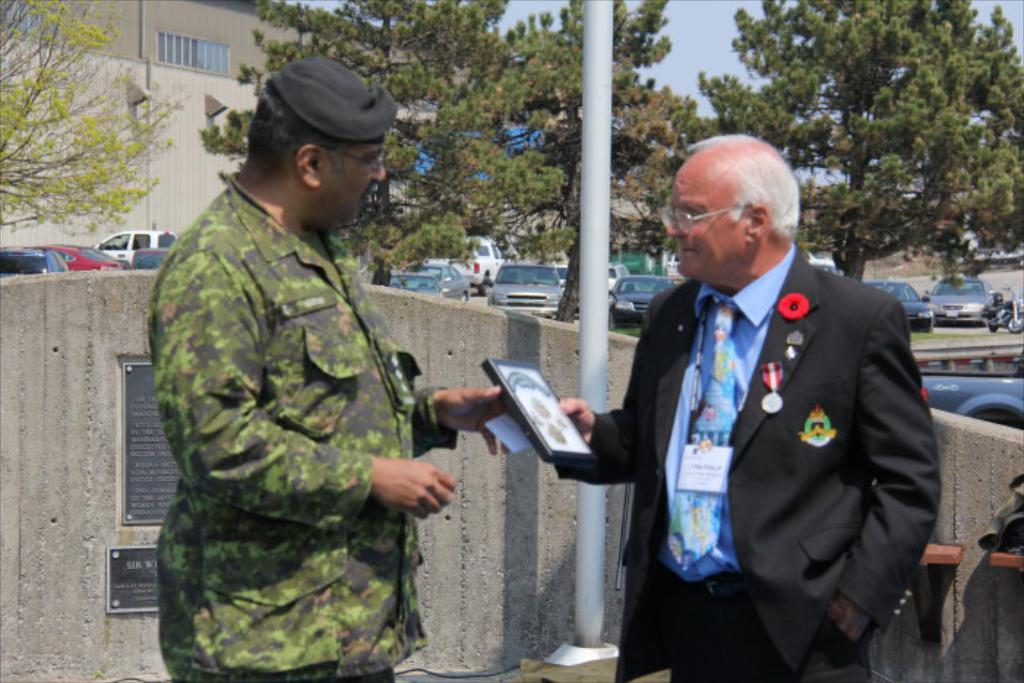How many people are in the image? There are two persons in the image. What can be seen in the image besides the people? There is an object in the image. What is visible in the background of the image? In the background of the image, there is a wall, vehicles, trees, buildings, a pole, and other objects. What part of the natural environment is visible in the image? The sky is visible in the background of the image. What type of eggs are being used to stitch the cakes in the image? There are no eggs or cakes present in the image, so it is not possible to answer that question. 